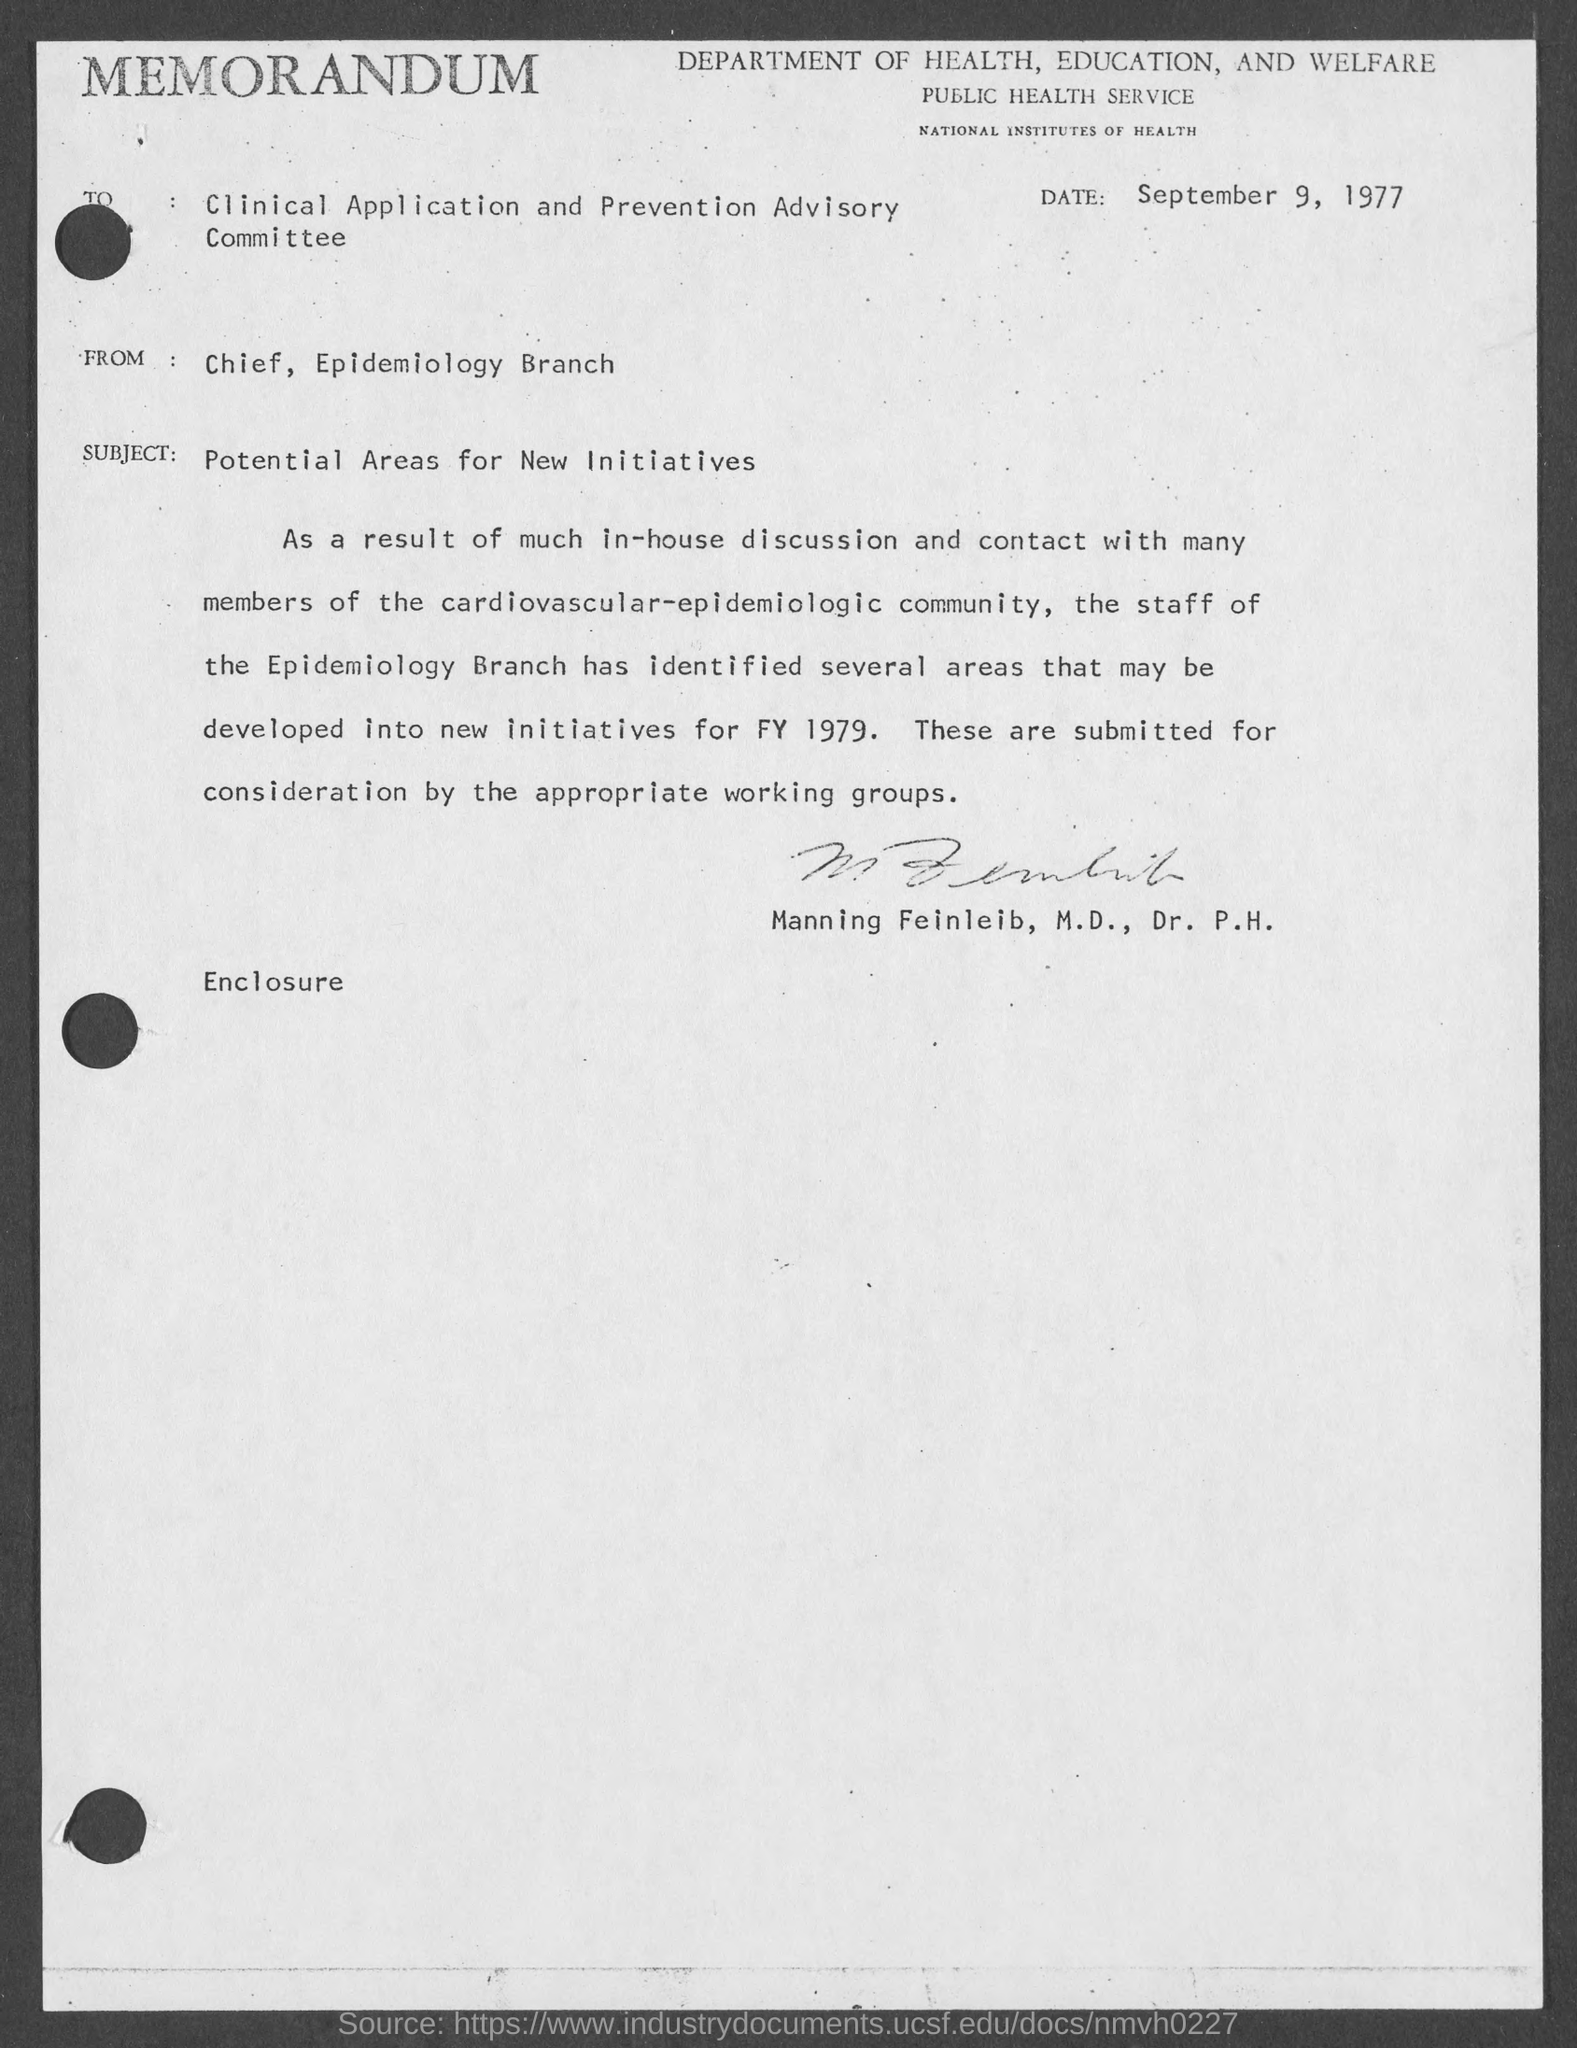Indicate a few pertinent items in this graphic. The subject of the memorandum is the potential areas for new initiatives. The from address in a memorandum is "Chief, Epidemiology Branch. The memorandum is dated September 9, 1977. 